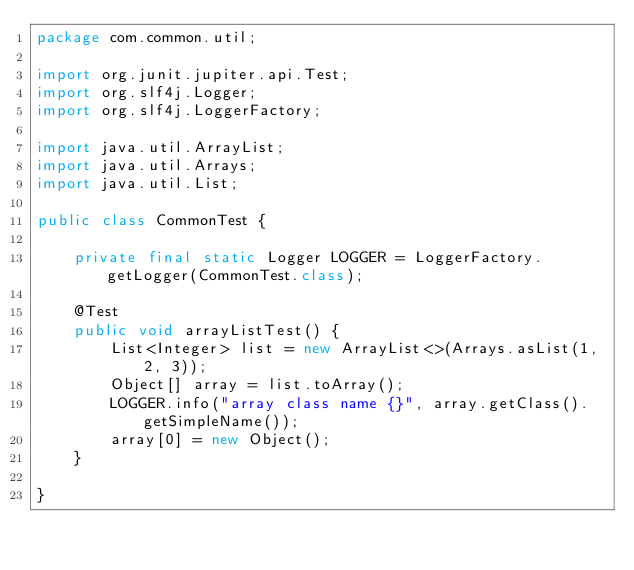Convert code to text. <code><loc_0><loc_0><loc_500><loc_500><_Java_>package com.common.util;

import org.junit.jupiter.api.Test;
import org.slf4j.Logger;
import org.slf4j.LoggerFactory;

import java.util.ArrayList;
import java.util.Arrays;
import java.util.List;

public class CommonTest {

    private final static Logger LOGGER = LoggerFactory.getLogger(CommonTest.class);

    @Test
    public void arrayListTest() {
        List<Integer> list = new ArrayList<>(Arrays.asList(1, 2, 3));
        Object[] array = list.toArray();
        LOGGER.info("array class name {}", array.getClass().getSimpleName());
        array[0] = new Object();
    }

}
</code> 